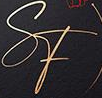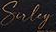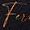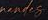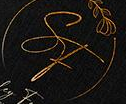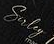What text appears in these images from left to right, separated by a semicolon? SF; Suley; Fu; #####; SF; Suley 